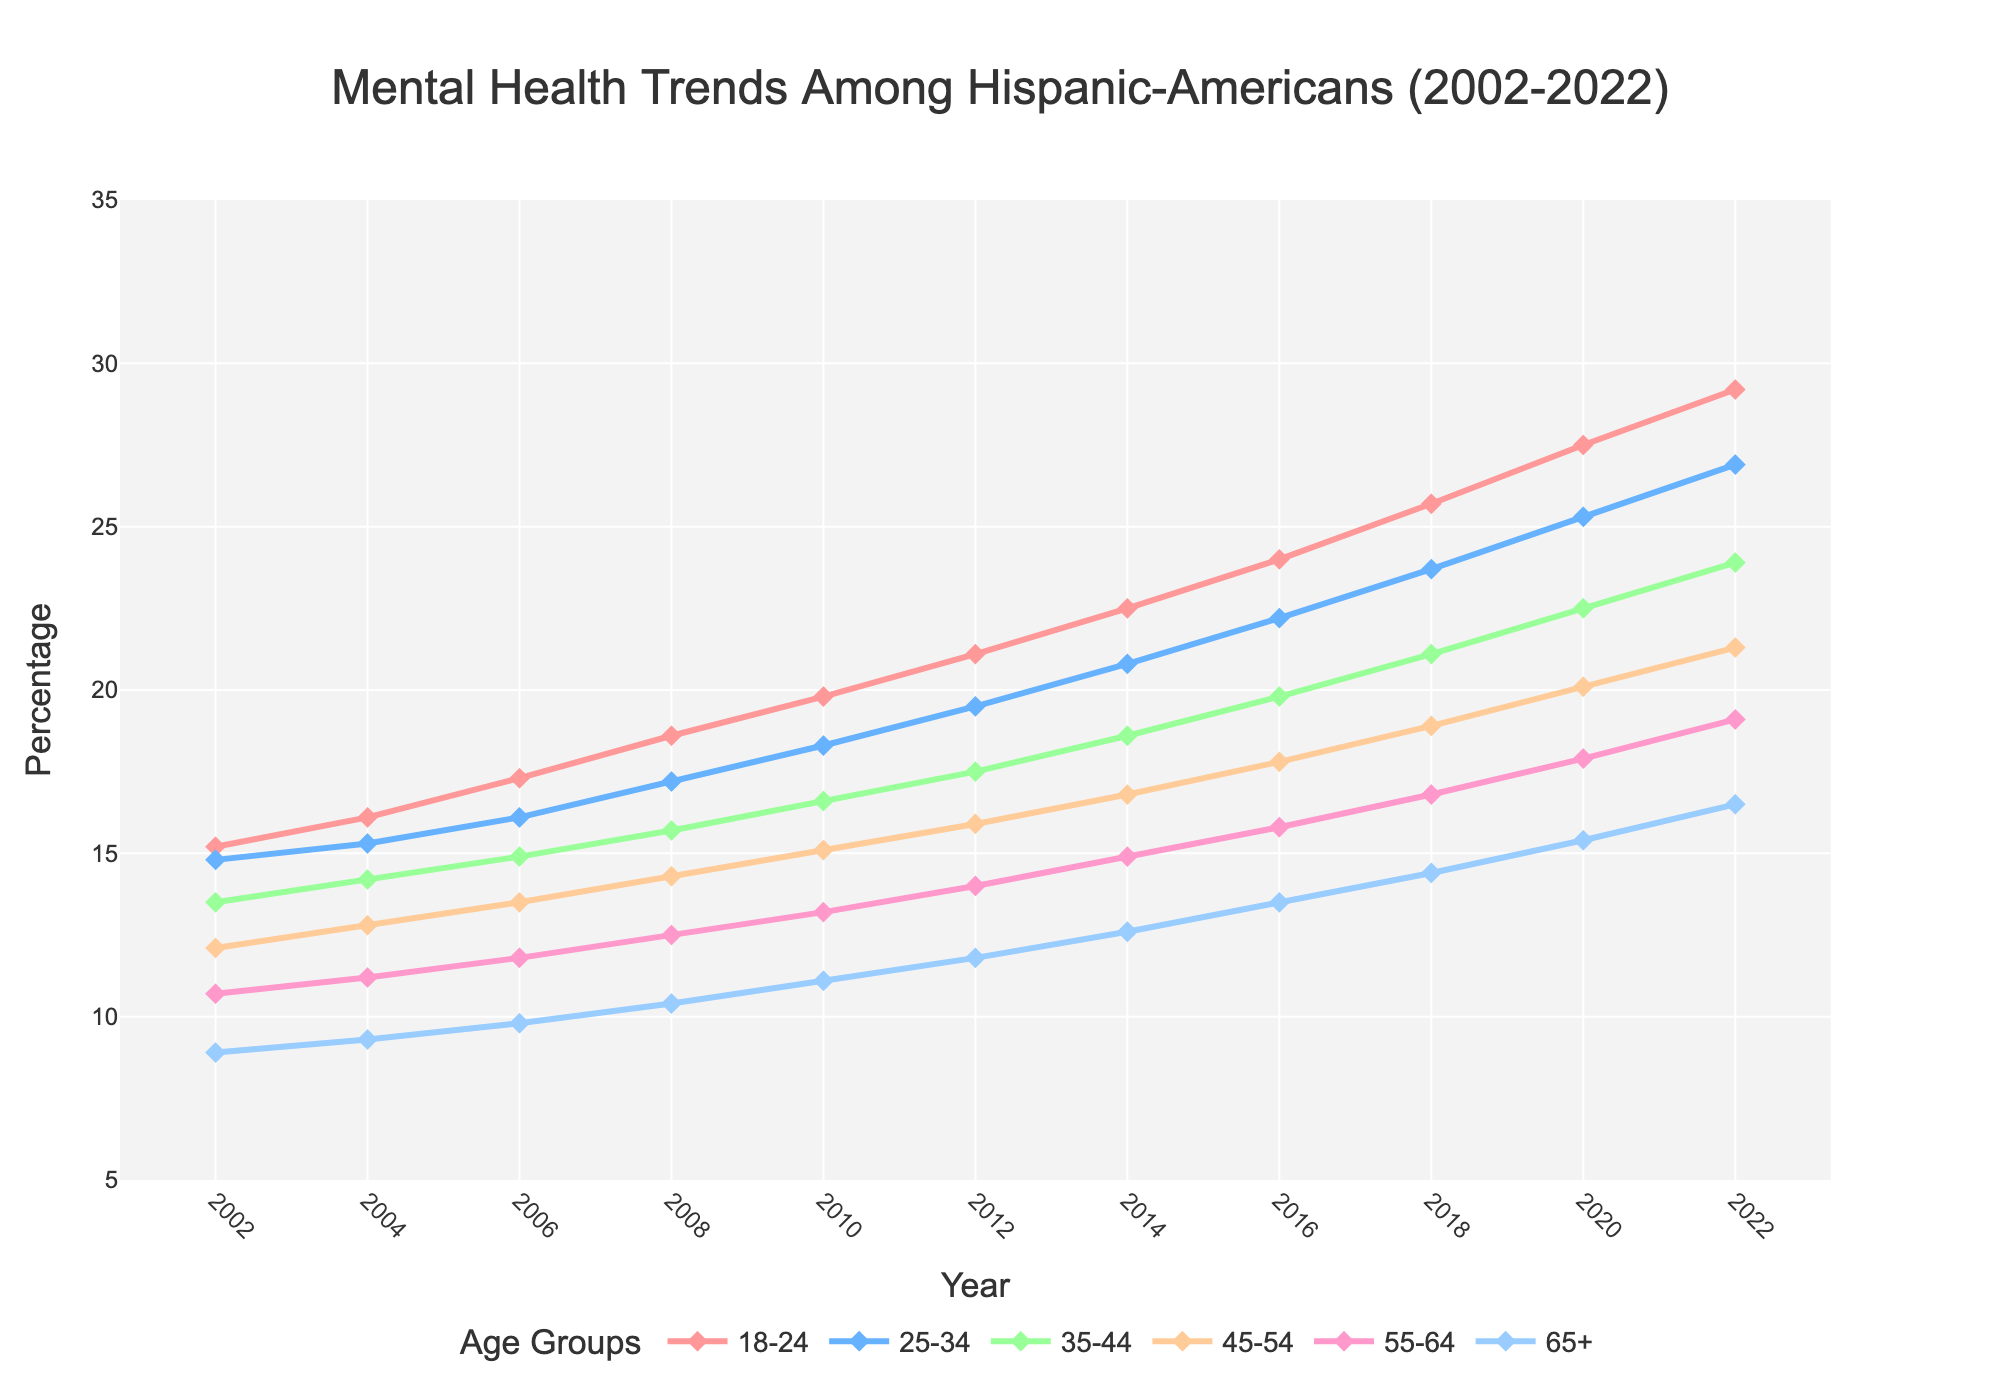What is the general trend of mental health percentages for the age group 18-24 over the 20 years? The mental health percentage for the 18-24 age group starts at 15.2% in 2002 and steadily increases each year, reaching 29.2% in 2022. Thus, the general trend is an upward one.
Answer: Upward Which age group had the highest mental health percentage in 2022? By observing the endpoints of the lines on the far right in 2022, the age group 18-24 has the highest mental health percentage at 29.2%.
Answer: 18-24 What is the percentage difference in mental health trends between age groups 18-24 and 65+ in 2022? In 2022, the percentage for the 18-24 age group is 29.2%, and for the 65+ age group, it is 16.5%. The difference is 29.2% - 16.5% = 12.7%.
Answer: 12.7% Which two age groups showed the most similar trends between 2008 and 2014? By examining the data points and lines between 2008 and 2014, the age groups 35-44 and 45-54 had close percentage values and similar trends in this span.
Answer: 35-44 and 45-54 In which years did the 55-64 age group mental health percentage cross above 15%? By tracking the line for the 55-64 age group, it crossed above 15% in 2014.
Answer: 2014 How has the gap between the age groups 18-24 and 25-34 changed from 2002 to 2022? In 2002, the gap between the 18-24 group (15.2%) and the 25-34 group (14.8%) was 15.2% - 14.8% = 0.4%. In 2022, the gap between 18-24 (29.2%) and 25-34 (26.9%) is 29.2% - 26.9% = 2.3%. The gap has widened over the years.
Answer: Widened What is the average mental health percentage for the age group 45-54 across all years? Sum the percentages for the 45-54 group across all years and divide by the number of years: (12.1 + 12.8 + 13.5 + 14.3 + 15.1 + 15.9 + 16.8 + 17.8 + 18.9 + 20.1 + 21.3) / 11.
Answer: 16.3 Which age group showed the most significant increase in mental health percentages from 2008 to 2010? By comparing the differences for each age group from 2008 to 2010: 18-24 (19.8 - 18.6 = 1.2), 25-34 (18.3 - 17.2 = 1.1), 35-44 (16.6 - 15.7 = 0.9), 45-54 (15.1 - 14.3 = 0.8), 55-64 (13.2 - 12.5 = 0.7), and 65+ (11.1 - 10.4 = 0.7). The 18-24 group shows the most significant increase.
Answer: 18-24 Which age group showed a consistently lower increase in mental health percentages over the 20 years? By examining the overall trends and percentages in the lines, the age group 65+ starts at 8.9% and ends at 16.5%, showing the slowest and lowest overall increase.
Answer: 65+ In which year did the mental health percentage of the 25-34 age group surpass 20%? The 25-34 age group crossed the 20% threshold in the year 2014.
Answer: 2014 